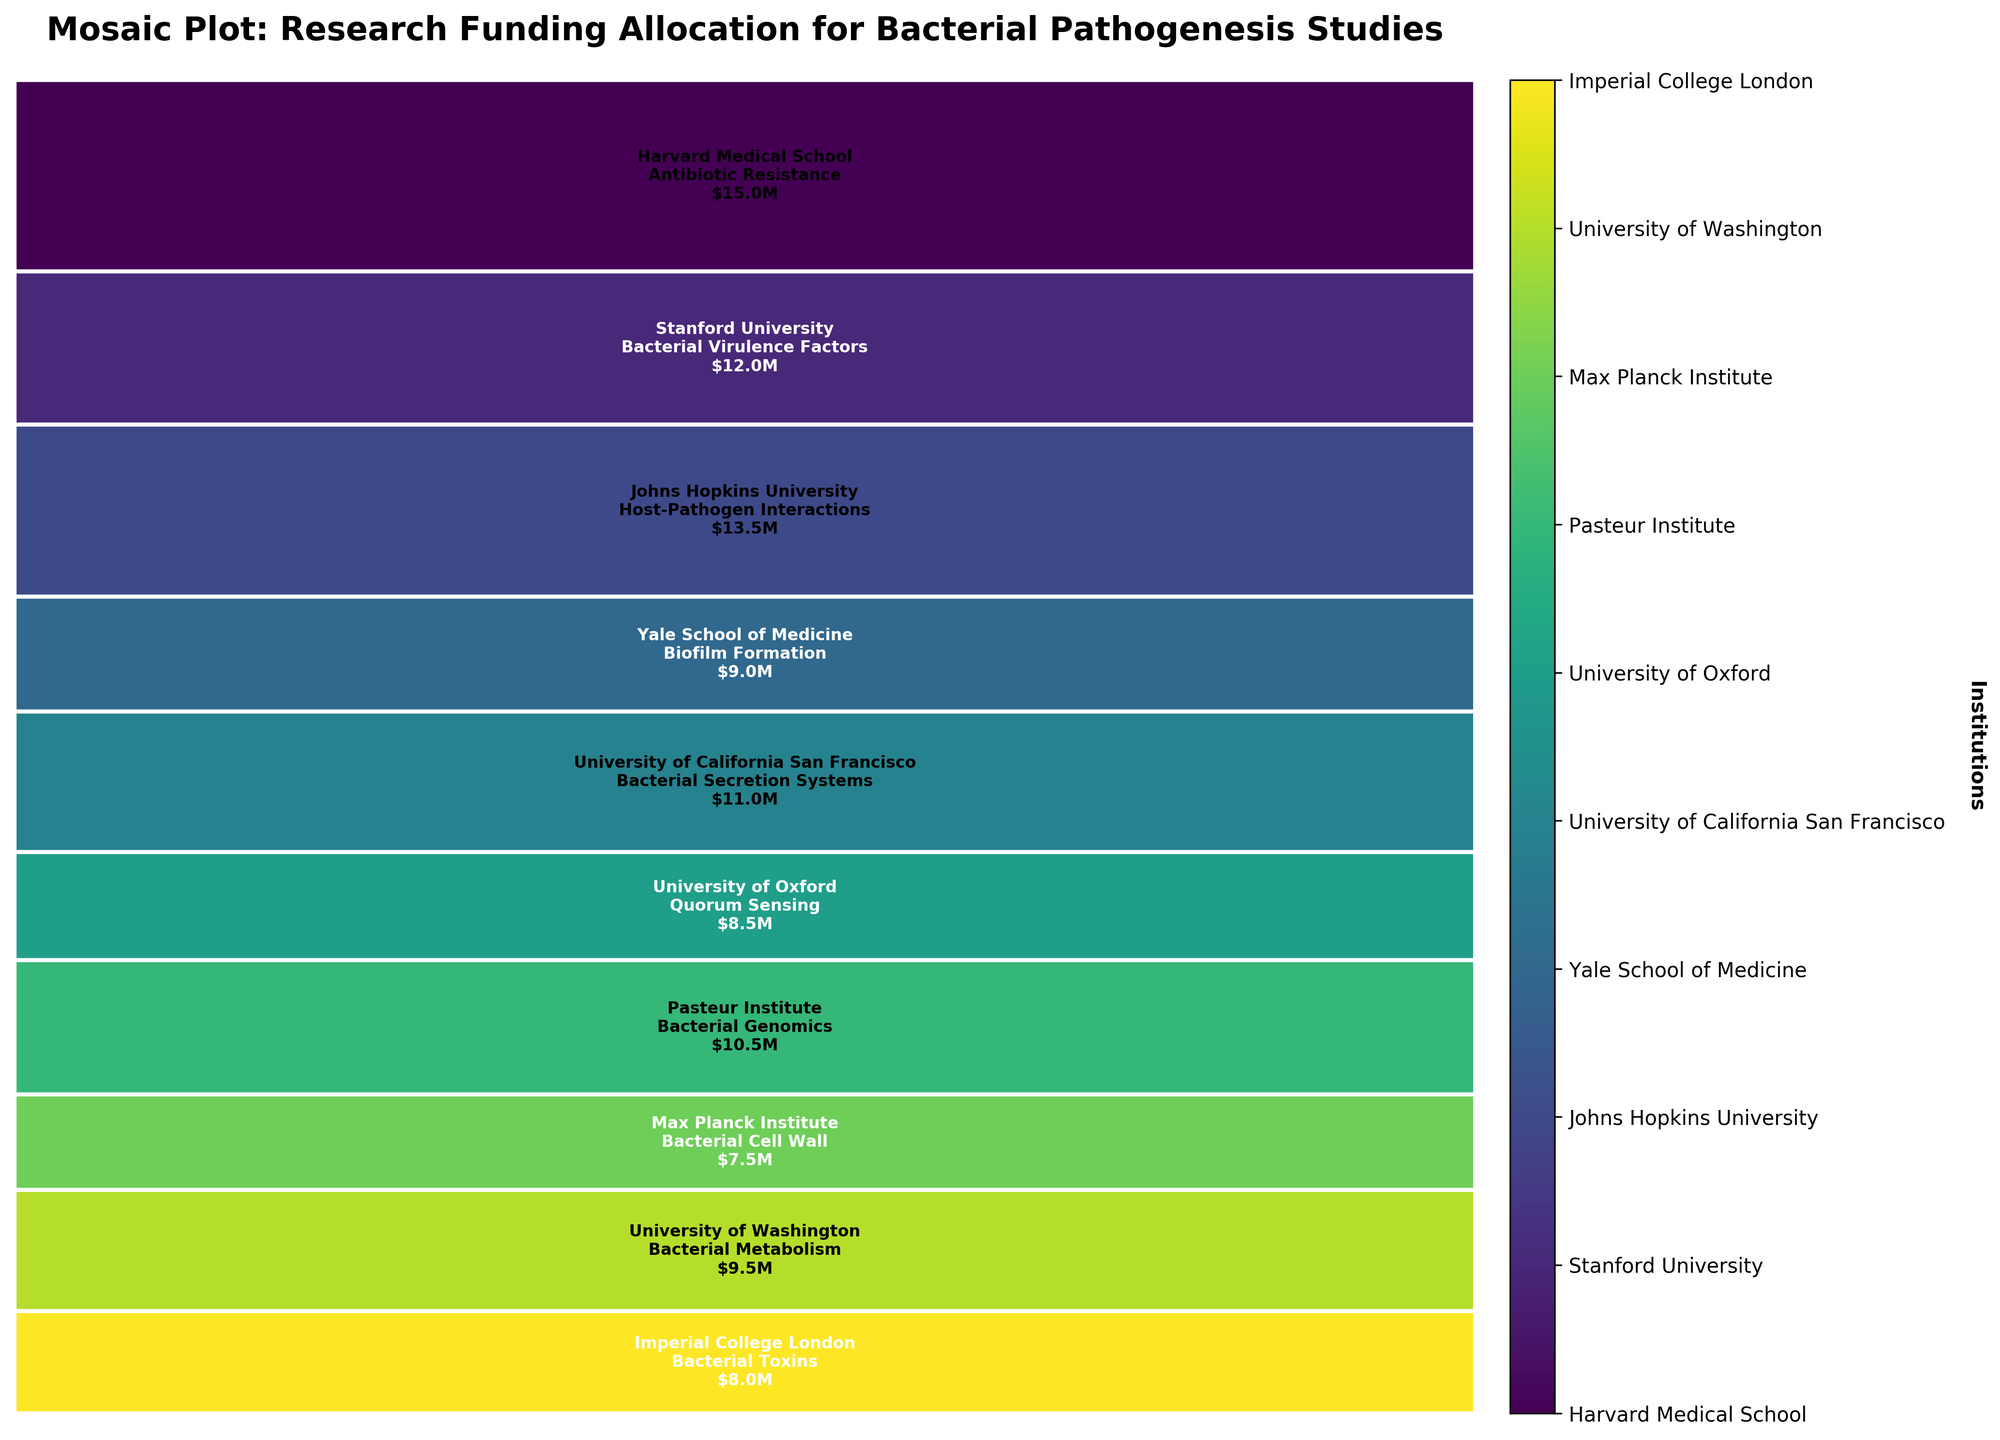What institution received the highest amount of funding? By examining the largest rectangle in the mosaic plot, the color and text indicate the institution with the highest funding. Harvard Medical School received the highest funding for Antibiotic Resistance research amounting to $15 million.
Answer: Harvard Medical School Which research area at the University of Oxford received funding, and how much was allocated? Look at the rectangle labeled with "University of Oxford" in the mosaic plot. The text within the rectangle indicates the research area and the funding amount. The University of Oxford received funding for Quorum Sensing research, amounting to $8.5 million.
Answer: Quorum Sensing, $8.5 million How does the funding allocation for Bacterial Virulence Factors compare to that of Bacterial Toxins? Identify the rectangles for Stanford University (Bacterial Virulence Factors) and Imperial College London (Bacterial Toxins). Compare their heights. Funding for Bacterial Virulence Factors is higher with $12 million compared to $8 million for Bacterial Toxins.
Answer: Bacterial Virulence Factors receives more funding than Bacterial Toxins What are the total allocations for institutions outside the United States? Identify and sum the funding amounts for the Pasteur Institute, Max Planck Institute, University of Oxford, and Imperial College London. Add up $10.5 million (Pasteur Institute), $7.5 million (Max Planck Institute), $8.5 million (University of Oxford), and $8 million (Imperial College London). The total funding is $34.5 million.
Answer: $34.5 million Which research area received the lowest funding, and which institution is it associated with? By examining the smallest rectangle in the mosaic plot and considering the funding values, it indicates the funding for the research area. The funding for Bacterial Cell Wall research at the Max Planck Institute was the lowest, at $7.5 million.
Answer: Bacterial Cell Wall, Max Planck Institute How much more funding did Host-Pathogen Interactions receive compared to Biofilm Formation? Compare the funding for Johns Hopkins University (Host-Pathogen Interactions) and Yale School of Medicine (Biofilm Formation). Subtract $9 million (Biofilm Formation) from $13.5 million (Host-Pathogen Interactions). Host-Pathogen Interactions received $4.5 million more funding than Biofilm Formation.
Answer: $4.5 million Is the average funding allocation across all institutions greater than $10 million? Calculate the total funding for all institutions, which is $96 million. Divide by the number of institutions (10). The average funding is $9.6 million. Since $9.6 million is not greater than $10 million, the average funding allocation is less than $10 million.
Answer: No Which research areas fall within the $9 million to $11 million funding range? Observe the rectangles for funding values between $9 million and $11 million. Bacterial Metabolism at University of Washington ($9.5 million), Bacterial Secretion Systems at University of California San Francisco ($11 million), and Bacterial Genomics at Pasteur Institute ($10.5 million) fall within this range.
Answer: Bacterial Metabolism, Bacterial Secretion Systems, Bacterial Genomics What is the percentage of the total funding allocated to Antibiotic Resistance research? Identify the funding for Antibiotic Resistance ($15 million). Divide by the total funding ($96 million) and multiply by 100 for the percentage. ($15 million / $96 million) * 100 = 15.63%.
Answer: 15.63% 